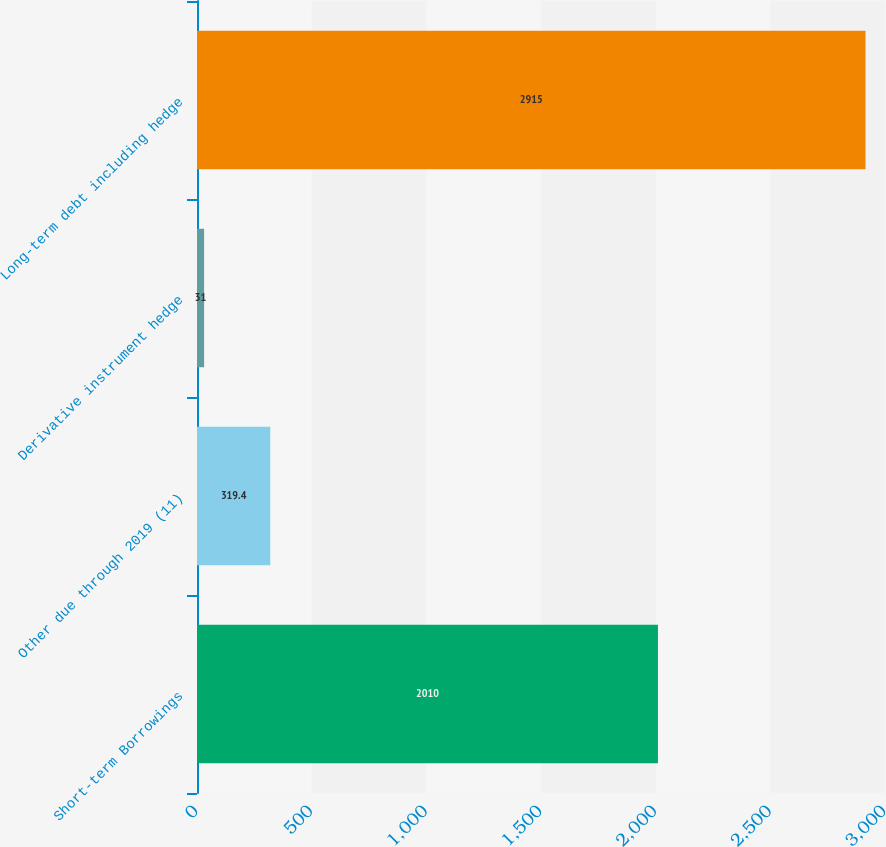<chart> <loc_0><loc_0><loc_500><loc_500><bar_chart><fcel>Short-term Borrowings<fcel>Other due through 2019 (11)<fcel>Derivative instrument hedge<fcel>Long-term debt including hedge<nl><fcel>2010<fcel>319.4<fcel>31<fcel>2915<nl></chart> 